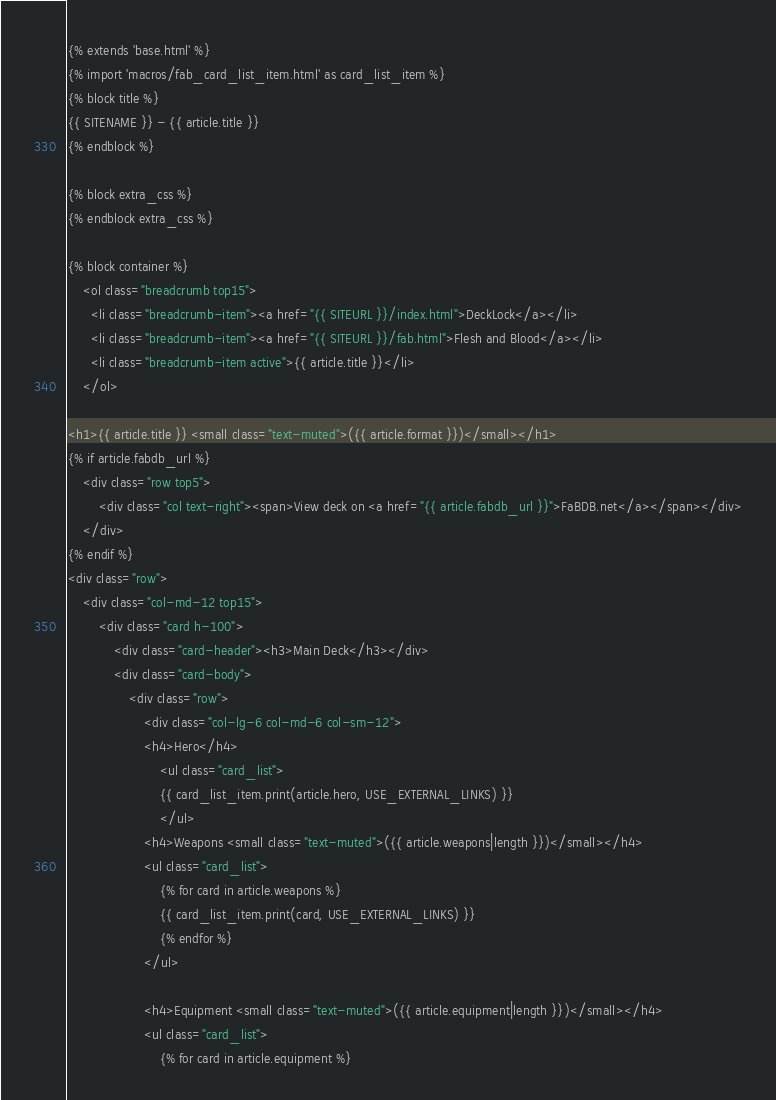<code> <loc_0><loc_0><loc_500><loc_500><_HTML_>{% extends 'base.html' %}
{% import 'macros/fab_card_list_item.html' as card_list_item %}
{% block title %}
{{ SITENAME }} - {{ article.title }}
{% endblock %}

{% block extra_css %}
{% endblock extra_css %}

{% block container %}
    <ol class="breadcrumb top15">
      <li class="breadcrumb-item"><a href="{{ SITEURL }}/index.html">DeckLock</a></li>
      <li class="breadcrumb-item"><a href="{{ SITEURL }}/fab.html">Flesh and Blood</a></li>
      <li class="breadcrumb-item active">{{ article.title }}</li>
    </ol>

<h1>{{ article.title }} <small class="text-muted">({{ article.format }})</small></h1>
{% if article.fabdb_url %}
    <div class="row top5">
        <div class="col text-right"><span>View deck on <a href="{{ article.fabdb_url }}">FaBDB.net</a></span></div>
    </div>
{% endif %}
<div class="row">
    <div class="col-md-12 top15">
        <div class="card h-100">
            <div class="card-header"><h3>Main Deck</h3></div>
            <div class="card-body">
                <div class="row">
                    <div class="col-lg-6 col-md-6 col-sm-12">
                    <h4>Hero</h4>
                        <ul class="card_list">
                        {{ card_list_item.print(article.hero, USE_EXTERNAL_LINKS) }}
                        </ul>
                    <h4>Weapons <small class="text-muted">({{ article.weapons|length }})</small></h4>
                    <ul class="card_list">
                        {% for card in article.weapons %}
                        {{ card_list_item.print(card, USE_EXTERNAL_LINKS) }}
                        {% endfor %}
                    </ul>

                    <h4>Equipment <small class="text-muted">({{ article.equipment|length }})</small></h4>
                    <ul class="card_list">
                        {% for card in article.equipment %}</code> 